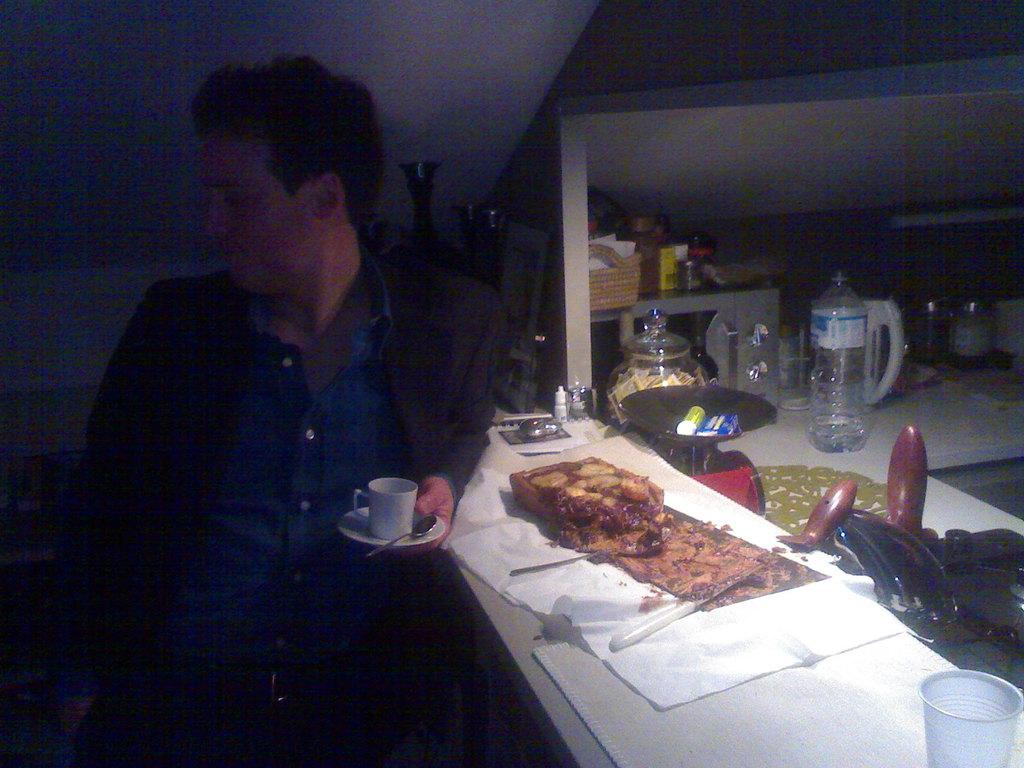What is the man in the image holding? The man is holding a cup and saucer in the image. What is on the table in the image? There is a food item, a spoon, a cloth, and a glass on the table in the image. Can you describe the table in the image? The table is where the food item, spoon, cloth, and glass are placed. What type of milk is being poured into the glass in the image? There is no milk present in the image, nor is there any indication of pouring. 